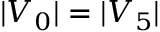Convert formula to latex. <formula><loc_0><loc_0><loc_500><loc_500>| V _ { 0 } | = | V _ { 5 } |</formula> 